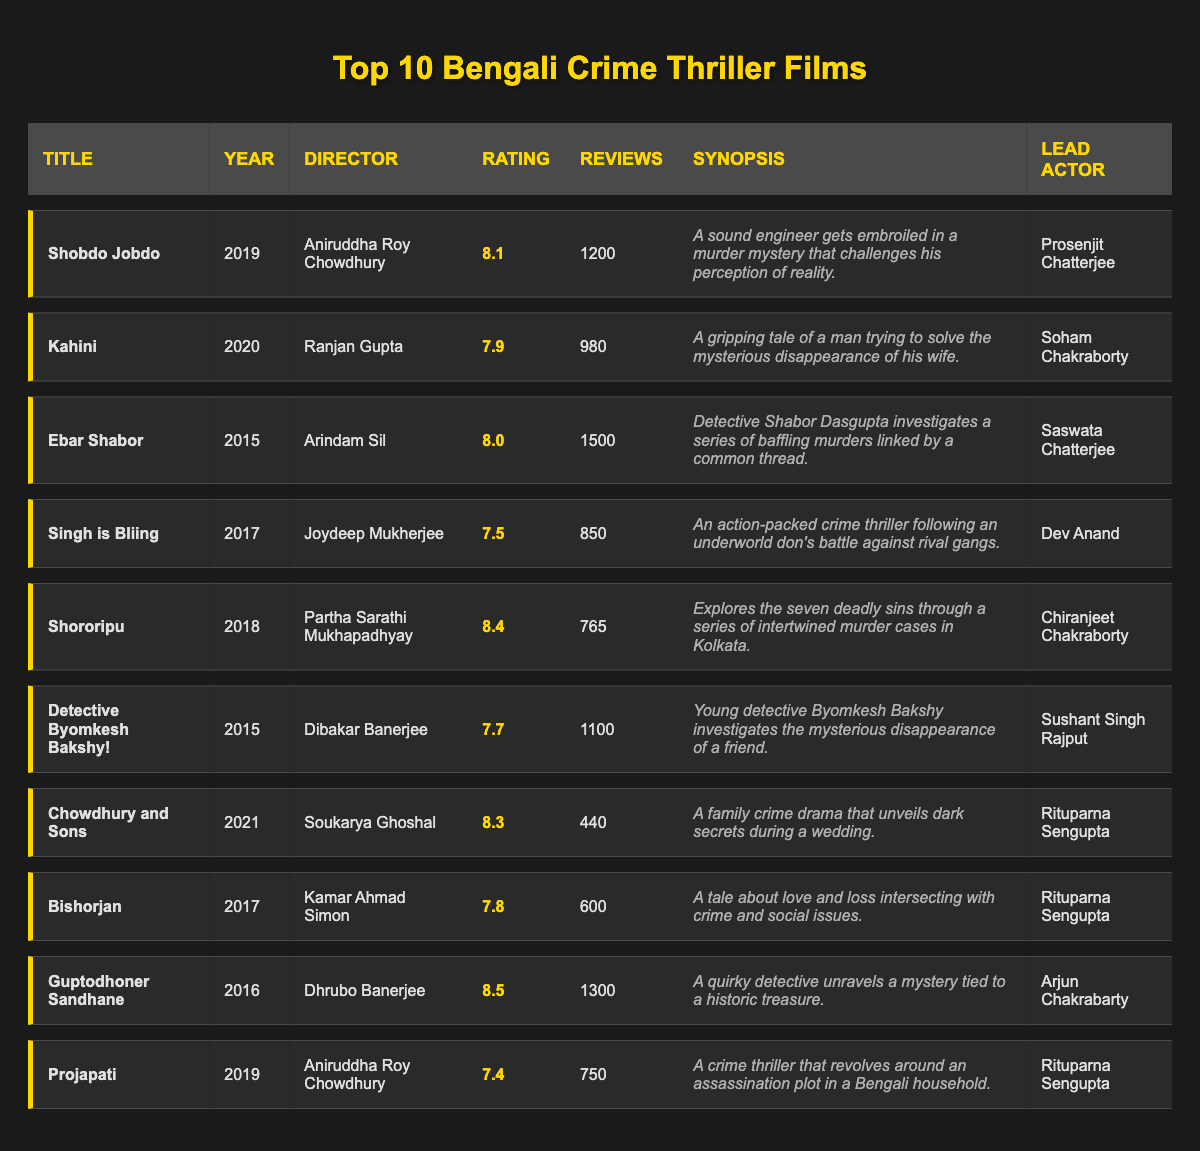What is the highest-rated film in the table? The highest rating in the "Rating" column is 8.5 for "Guptodhoner Sandhane." Therefore, that film has the highest viewer rating among the listed movies.
Answer: Guptodhoner Sandhane How many reviews does "Ebar Shabor" have? Referring to the "Reviews" column, "Ebar Shabor" has a total of 1500 reviews as noted in the corresponding row.
Answer: 1500 Which film features the actor Prosenjit Chatterjee? By checking the "Lead Actor" column, it is found that "Shobdo Jobdo" features Prosenjit Chatterjee, as indicated in that row.
Answer: Shobdo Jobdo What is the average rating of films directed by Aniruddha Roy Chowdhury? The films directed by Aniruddha Roy Chowdhury are "Shobdo Jobdo" with a rating of 8.1 and "Projapati" with a rating of 7.4. Adding them gives 8.1 + 7.4 = 15.5, and dividing by 2 results in an average rating of 7.75.
Answer: 7.75 Did any film released in 2017 receive a rating above 8? Checking the "Year" and "Rating" columns for 2017, "Guptodhoner Sandhane" has a rating of 8.5, which is indeed above 8, confirming that at least one film did.
Answer: Yes 